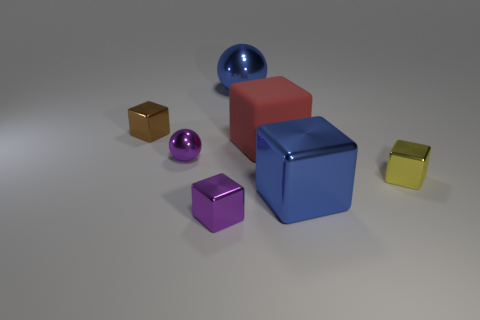Subtract all brown cubes. How many cubes are left? 4 Subtract all purple spheres. How many spheres are left? 1 Subtract all spheres. How many objects are left? 5 Subtract 1 balls. How many balls are left? 1 Add 3 yellow shiny things. How many objects exist? 10 Subtract all yellow balls. Subtract all cyan cylinders. How many balls are left? 2 Subtract all gray cylinders. How many gray blocks are left? 0 Subtract all big rubber objects. Subtract all small gray metallic cubes. How many objects are left? 6 Add 7 yellow metallic objects. How many yellow metallic objects are left? 8 Add 3 red matte cubes. How many red matte cubes exist? 4 